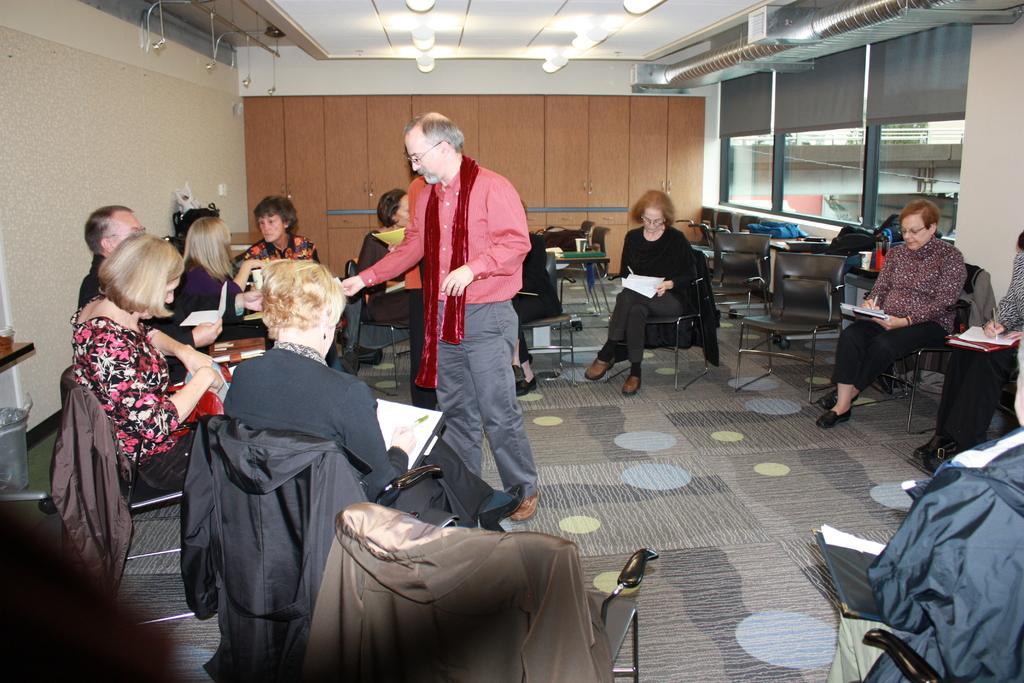Please provide a concise description of this image. There are group of people sitting on the chairs and holding papers. These are the jerkins, which are hanging on the chairs. I can see two people standing. These look like the cupboards with the wooden doors. I can see the ceiling lights attached to the roof. These are the windows with the glass doors. On the left side of the image, that looks like a dustbin, which is under the table. These are the kind of curtains hanging to the hanger. 